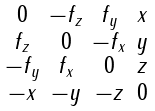Convert formula to latex. <formula><loc_0><loc_0><loc_500><loc_500>\begin{smallmatrix} 0 & - f _ { z } & f _ { y } & x \\ f _ { z } & 0 & - f _ { x } & y \\ - f _ { y } & f _ { x } & 0 & z \\ - x & - y & - z & 0 \end{smallmatrix}</formula> 